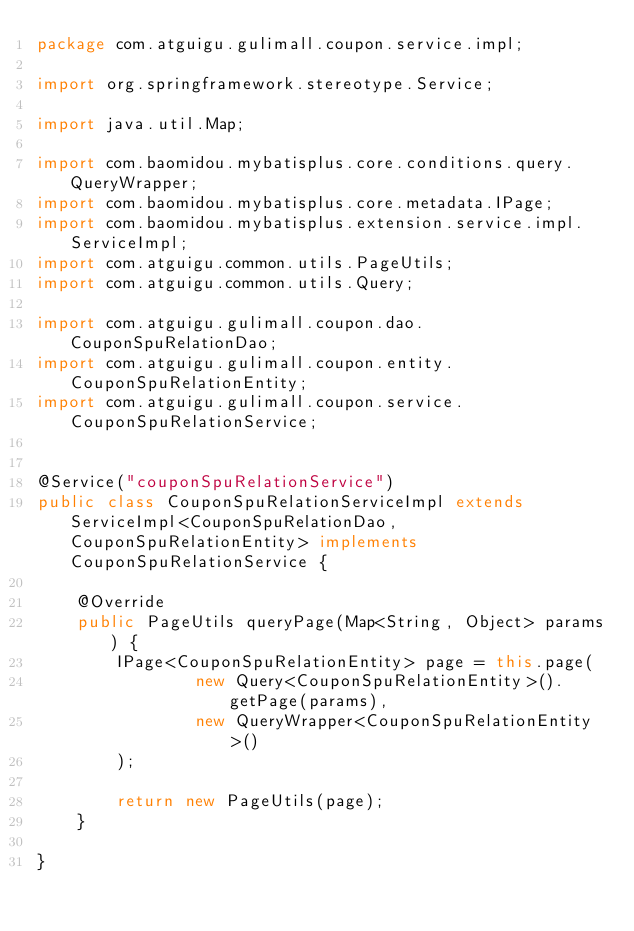<code> <loc_0><loc_0><loc_500><loc_500><_Java_>package com.atguigu.gulimall.coupon.service.impl;

import org.springframework.stereotype.Service;

import java.util.Map;

import com.baomidou.mybatisplus.core.conditions.query.QueryWrapper;
import com.baomidou.mybatisplus.core.metadata.IPage;
import com.baomidou.mybatisplus.extension.service.impl.ServiceImpl;
import com.atguigu.common.utils.PageUtils;
import com.atguigu.common.utils.Query;

import com.atguigu.gulimall.coupon.dao.CouponSpuRelationDao;
import com.atguigu.gulimall.coupon.entity.CouponSpuRelationEntity;
import com.atguigu.gulimall.coupon.service.CouponSpuRelationService;


@Service("couponSpuRelationService")
public class CouponSpuRelationServiceImpl extends ServiceImpl<CouponSpuRelationDao, CouponSpuRelationEntity> implements CouponSpuRelationService {

    @Override
    public PageUtils queryPage(Map<String, Object> params) {
        IPage<CouponSpuRelationEntity> page = this.page(
                new Query<CouponSpuRelationEntity>().getPage(params),
                new QueryWrapper<CouponSpuRelationEntity>()
        );

        return new PageUtils(page);
    }

}</code> 